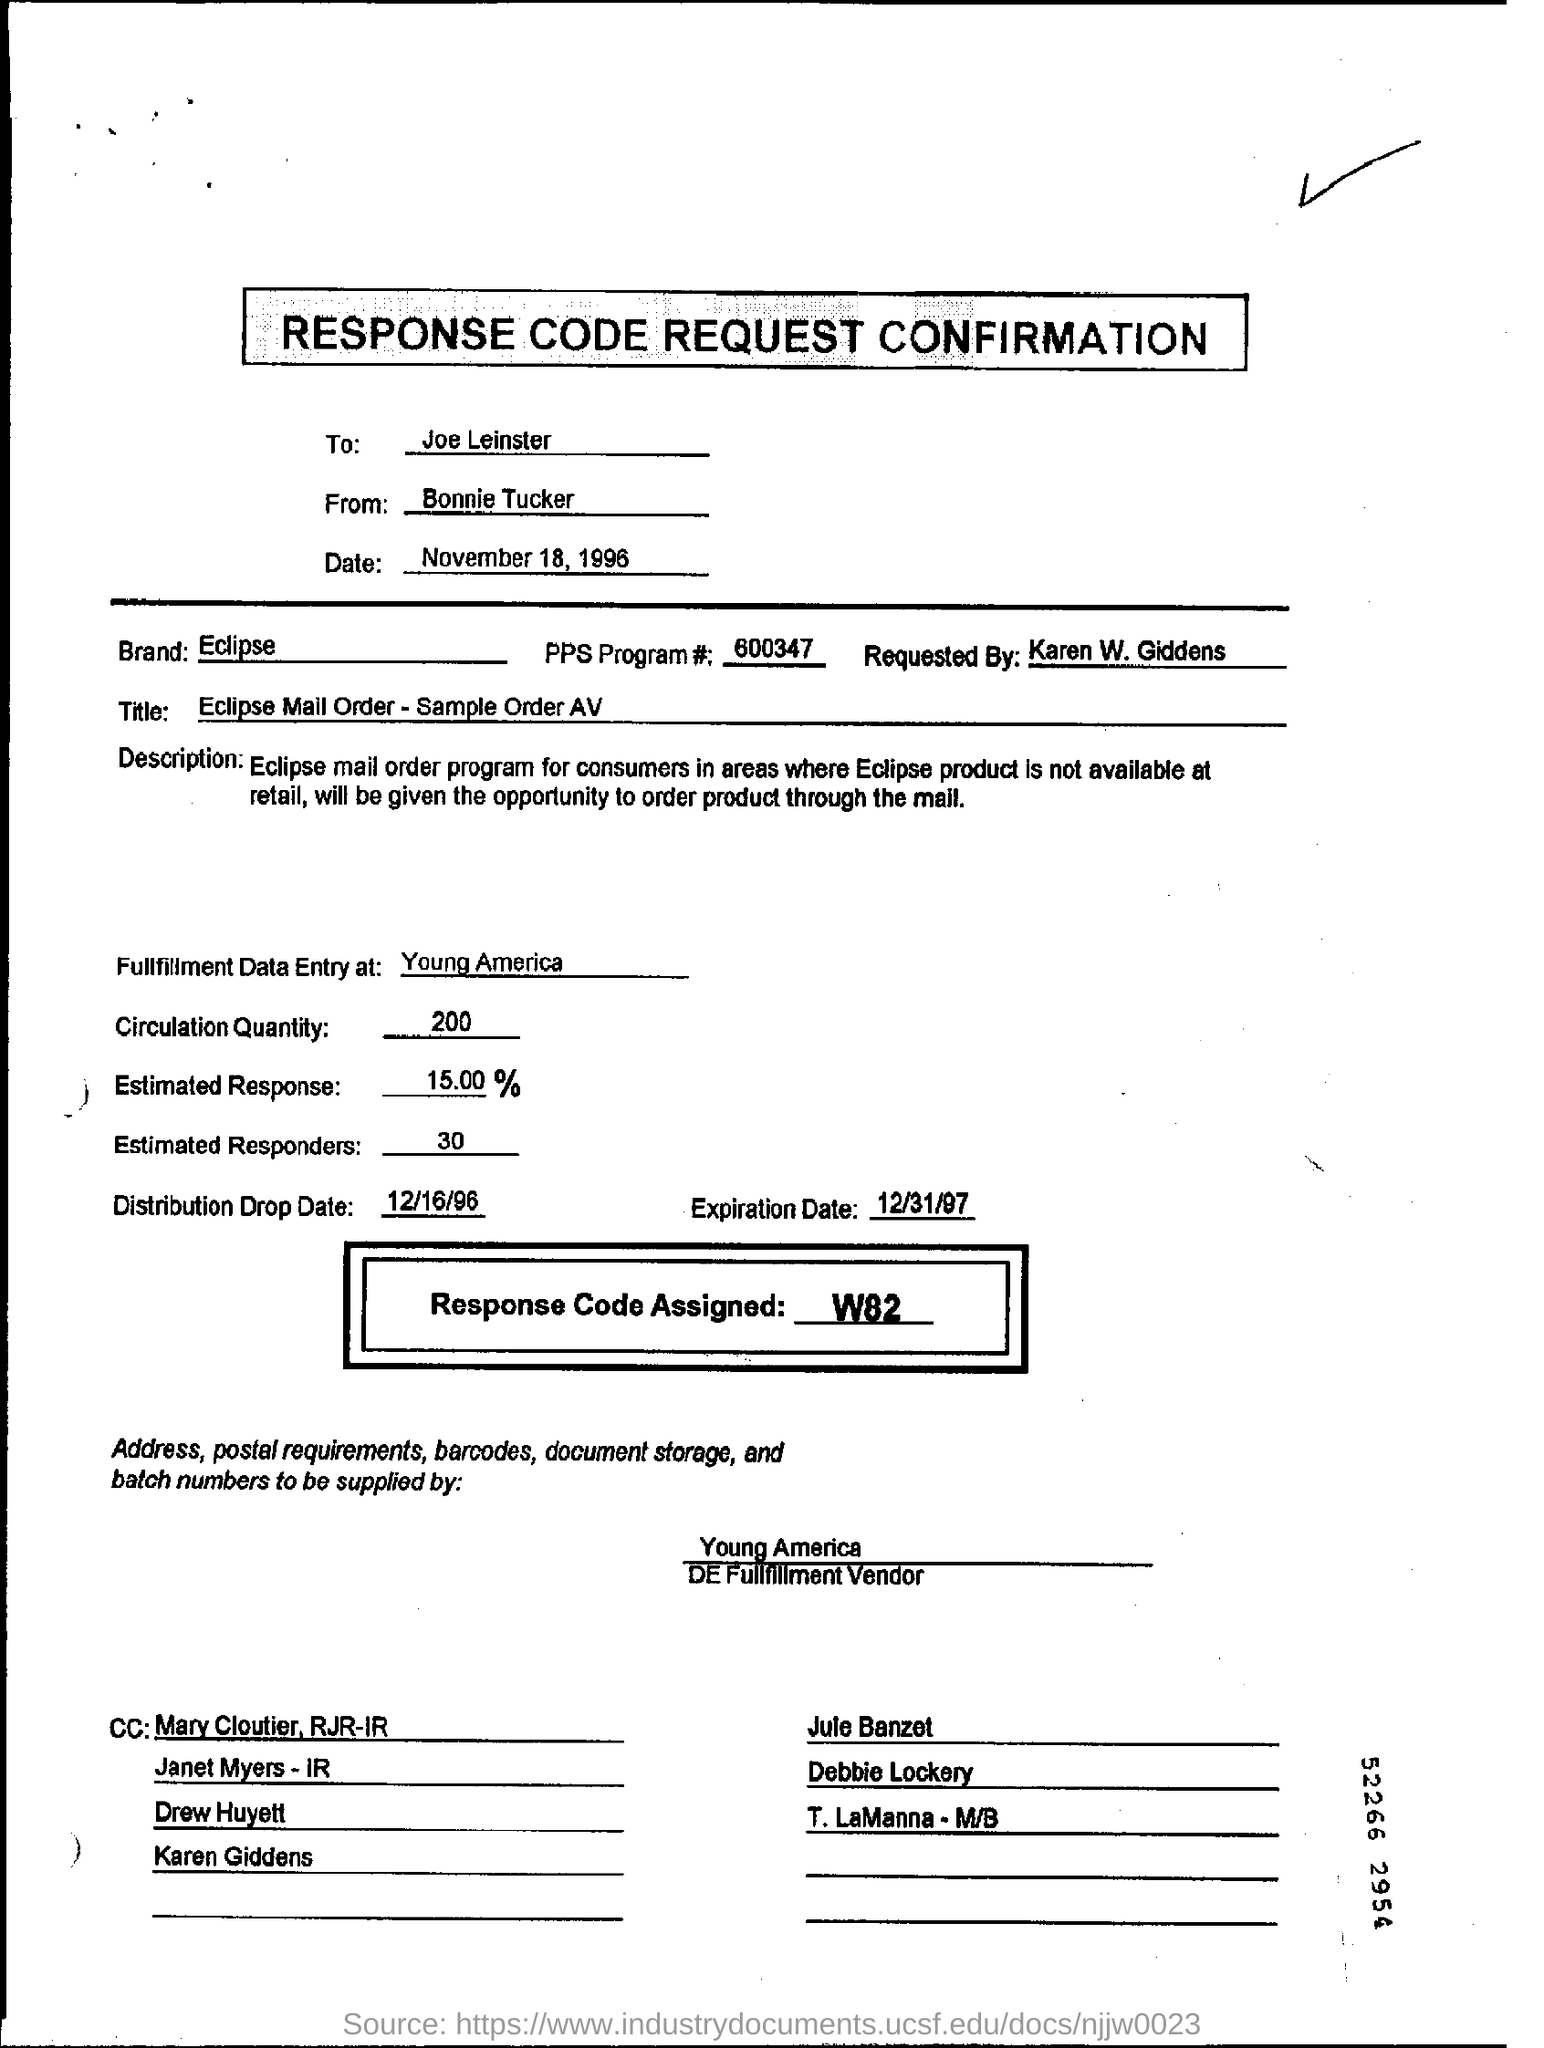To whom is the confirmation addressed?
Your response must be concise. Joe Leinster. How much is the Circulation Quantity?
Your response must be concise. 200. Which is the Response Code  Assigned?
Make the answer very short. W82. To whom is the first CC marked to?
Offer a terse response. Mary Cloutier, RJR-IR. 